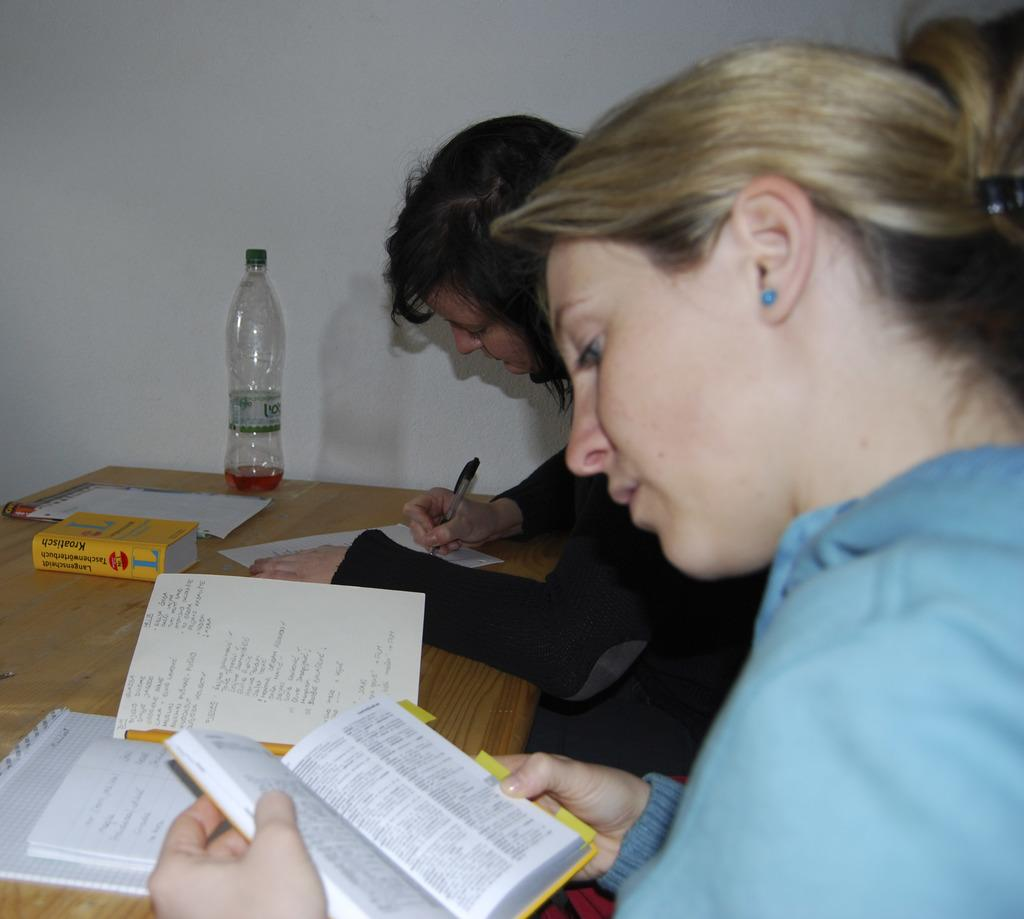<image>
Write a terse but informative summary of the picture. Two girls are studying at a wooden table with a book on it called Kroatisch. 